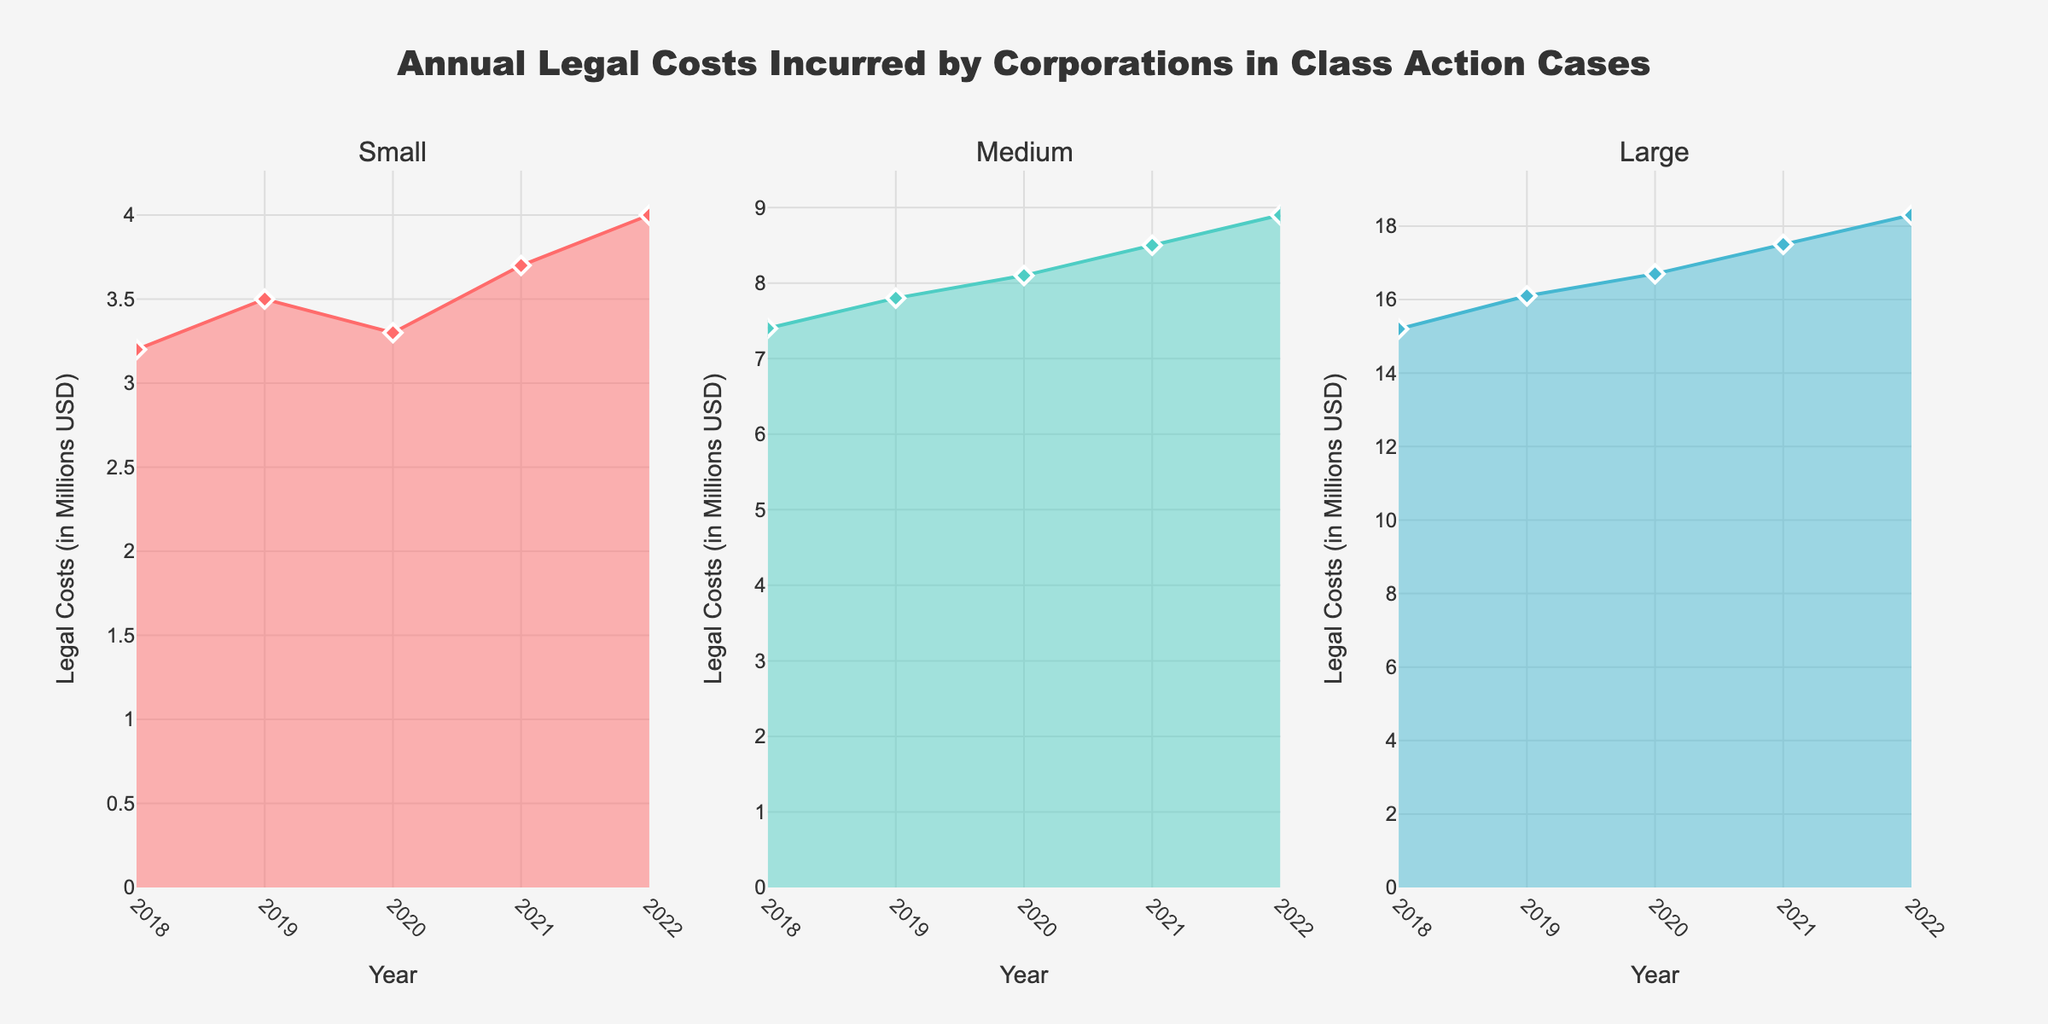What is the title of the figure? The title is displayed at the top center of the figure and is in bold. It reads: "Annual Legal Costs Incurred by Corporations in Class Action Cases".
Answer: Annual Legal Costs Incurred by Corporations in Class Action Cases What are the years covered in the figure? Each subplot has data points with years labeled along the x-axis; these years are 2018, 2019, 2020, 2021, and 2022.
Answer: 2018 to 2022 What color represents Small companies in the plot? The area chart for Small companies is colored, and it is also specified in the color list, which corresponds to red (#FF6B6B).
Answer: Red Which company size had the highest legal costs in 2022? Within each subplot, 2022 has the highest y-value compared to other years. Large companies have a value of 18.3 million USD in 2022, which is higher than the Medium companies' 8.9 million USD and Small companies' 4.0 million USD.
Answer: Large What is the trend in the legal costs for Medium companies from 2018 to 2022? The line chart shows an increasing slope for Medium companies, with legal costs steadily rising each year from 7.4 million USD in 2018 to 8.9 million USD in 2022.
Answer: Increasing How much did legal costs increase for Large companies from 2018 to 2022? Subtract the 2018 value from the 2022 value for Large companies: 18.3 million USD (2022) - 15.2 million USD (2018) = 3.1 million USD.
Answer: 3.1 million USD Compare the legal costs of Small and Medium companies in 2020. Which is higher and by how much? Figure shows Small companies at 3.3 million USD and Medium companies at 8.1 million USD in 2020. The difference is 8.1 million USD - 3.3 million USD = 4.8 million USD, with Medium being higher.
Answer: Medium by 4.8 million USD Which company size shows the most consistent increase in legal costs year over year? By observing the trends, Large companies' line chart shows a consistent upward trend from 2018 to 2022 without any dips, unlike Small and Medium which have slight fluctuations.
Answer: Large What is the average legal cost incurred by Small companies over the 5 years? Sum the values for Small companies: 3.2 + 3.5 + 3.3 + 3.7 + 4.0 = 17.7 million USD. Then divide by the number of years: 17.7 / 5 = 3.54 million USD.
Answer: 3.54 million USD 